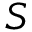<formula> <loc_0><loc_0><loc_500><loc_500>S</formula> 